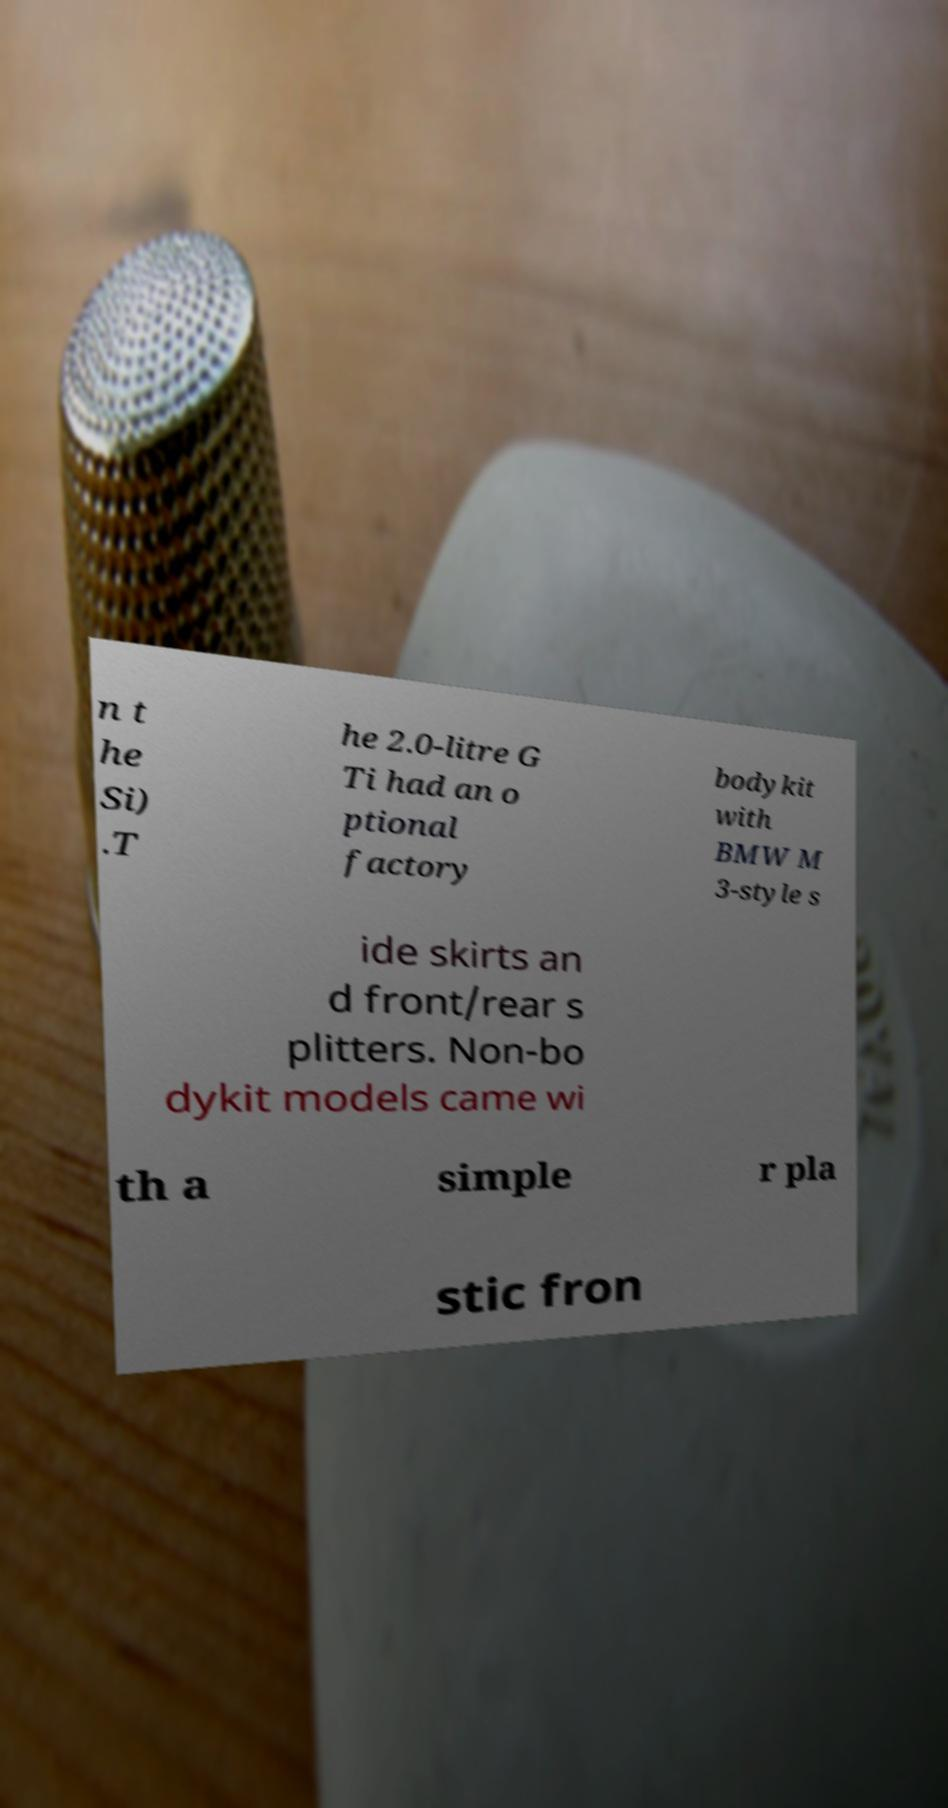Please identify and transcribe the text found in this image. n t he Si) .T he 2.0-litre G Ti had an o ptional factory bodykit with BMW M 3-style s ide skirts an d front/rear s plitters. Non-bo dykit models came wi th a simple r pla stic fron 